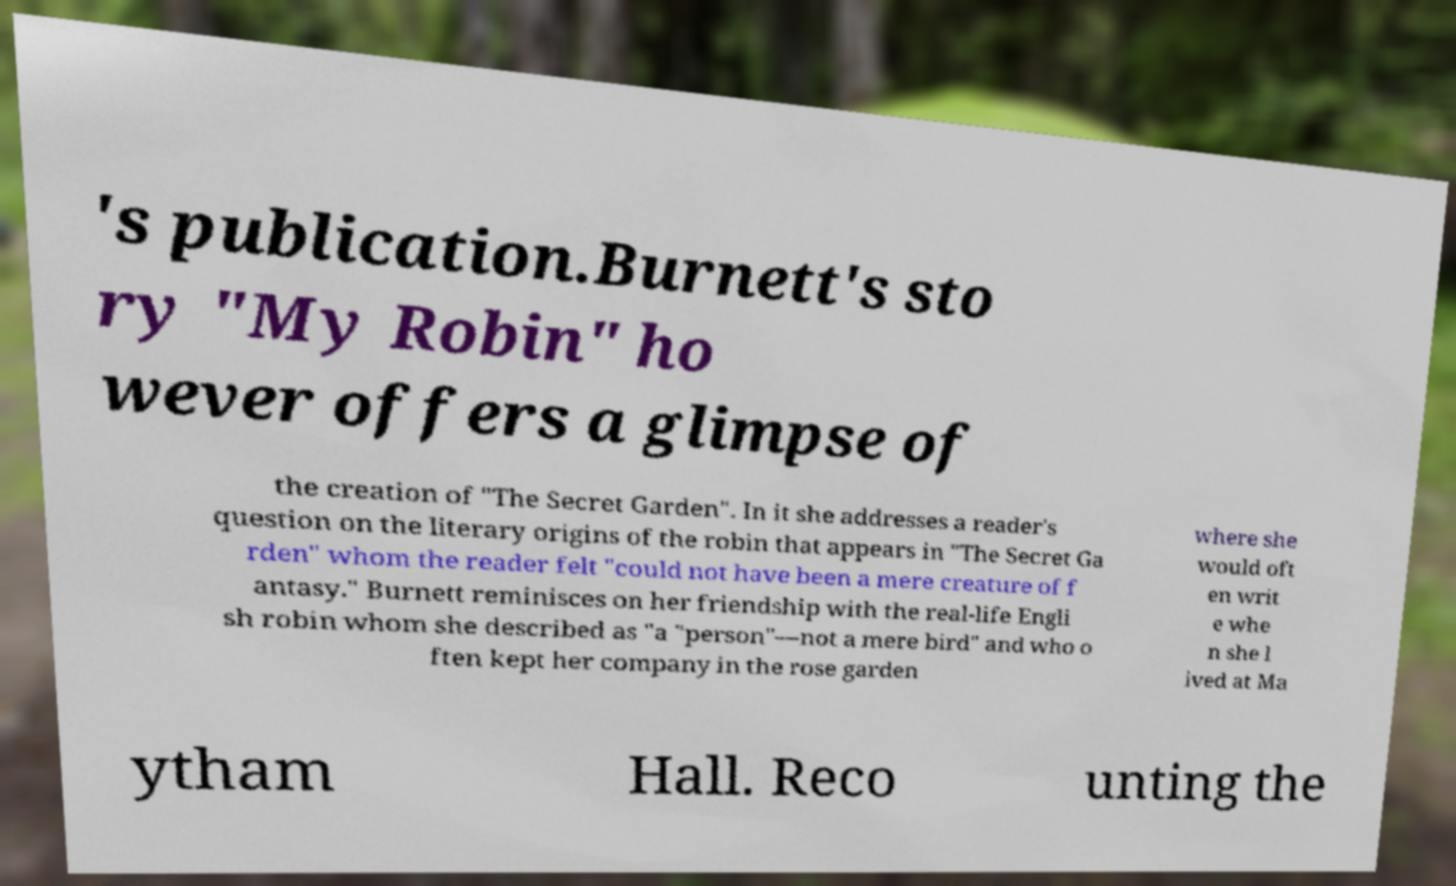For documentation purposes, I need the text within this image transcribed. Could you provide that? 's publication.Burnett's sto ry "My Robin" ho wever offers a glimpse of the creation of "The Secret Garden". In it she addresses a reader's question on the literary origins of the robin that appears in "The Secret Ga rden" whom the reader felt "could not have been a mere creature of f antasy." Burnett reminisces on her friendship with the real-life Engli sh robin whom she described as "a "person"—not a mere bird" and who o ften kept her company in the rose garden where she would oft en writ e whe n she l ived at Ma ytham Hall. Reco unting the 